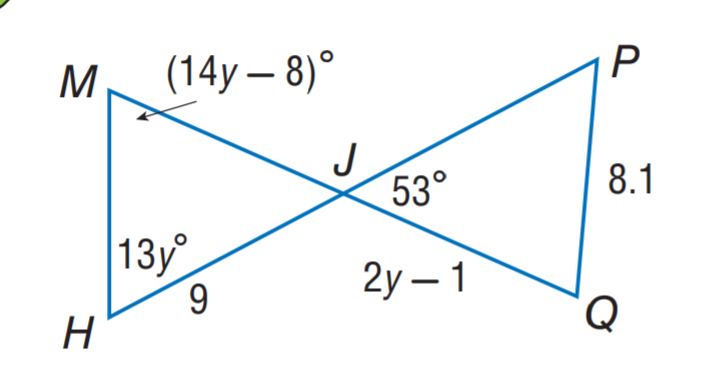Question: \triangle M H J \cong \triangle P Q J. Find y.
Choices:
A. 3
B. 4
C. 5
D. 6
Answer with the letter. Answer: C 